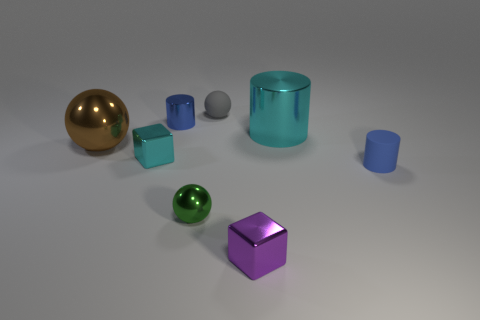Subtract all tiny metallic cylinders. How many cylinders are left? 2 Add 2 gray matte spheres. How many objects exist? 10 Subtract 1 cylinders. How many cylinders are left? 2 Subtract all blue cylinders. How many cylinders are left? 1 Subtract all brown balls. How many blue cylinders are left? 2 Add 2 matte cylinders. How many matte cylinders exist? 3 Subtract 1 gray balls. How many objects are left? 7 Subtract all cylinders. How many objects are left? 5 Subtract all green cylinders. Subtract all blue spheres. How many cylinders are left? 3 Subtract all balls. Subtract all small gray metallic cylinders. How many objects are left? 5 